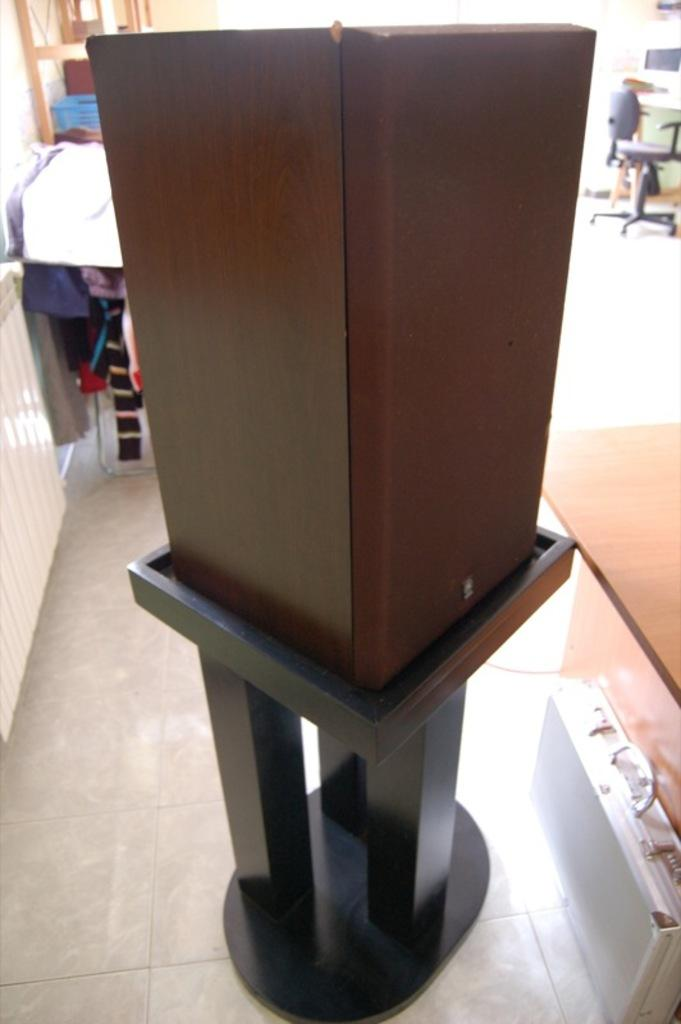What is on the stand in the image? There is a box on a stand in the image. What is located beside the stand? There is a suitcase beside the stand. What piece of furniture is present in the image? There is a table and a chair in the image. Can you describe the other objects present in the room? There are other objects present in the room, but their specific details are not mentioned in the provided facts. What type of pear is being used for arithmetic on the table in the image? There is no pear or arithmetic activity present in the image. Is there a letter addressed to someone on the chair in the image? There is no mention of a letter or any correspondence in the image. 